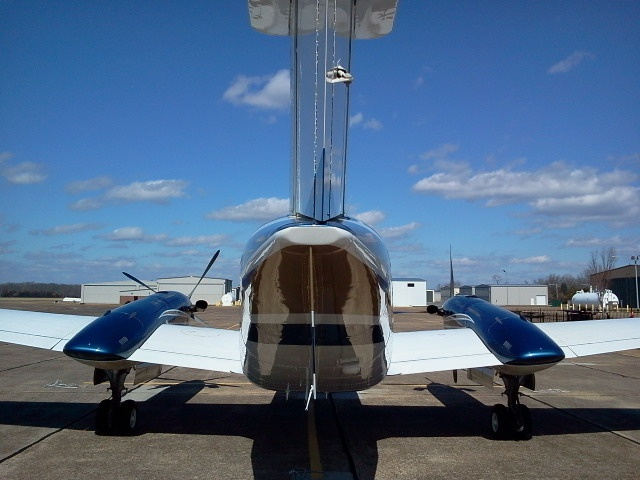Describe the objects in this image and their specific colors. I can see a airplane in blue, black, gray, and lightgray tones in this image. 